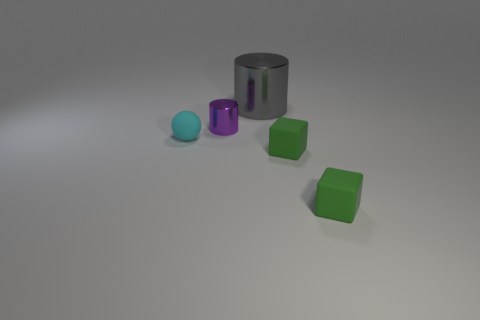There is a big gray thing that is made of the same material as the small purple object; what shape is it?
Offer a terse response. Cylinder. There is a metal cylinder that is the same size as the cyan ball; what is its color?
Your answer should be compact. Purple. There is a shiny cylinder in front of the gray thing; is its size the same as the gray shiny cylinder?
Ensure brevity in your answer.  No. Do the large object and the tiny metal cylinder have the same color?
Make the answer very short. No. How many shiny cylinders are there?
Your response must be concise. 2. How many balls are either cyan objects or small metallic things?
Your answer should be very brief. 1. What number of green things are behind the metal object that is left of the big gray object?
Provide a short and direct response. 0. Are the tiny cyan sphere and the gray thing made of the same material?
Provide a succinct answer. No. Is there a tiny green object made of the same material as the cyan sphere?
Offer a very short reply. Yes. There is a shiny cylinder that is in front of the cylinder that is behind the small object that is behind the cyan ball; what is its color?
Offer a very short reply. Purple. 